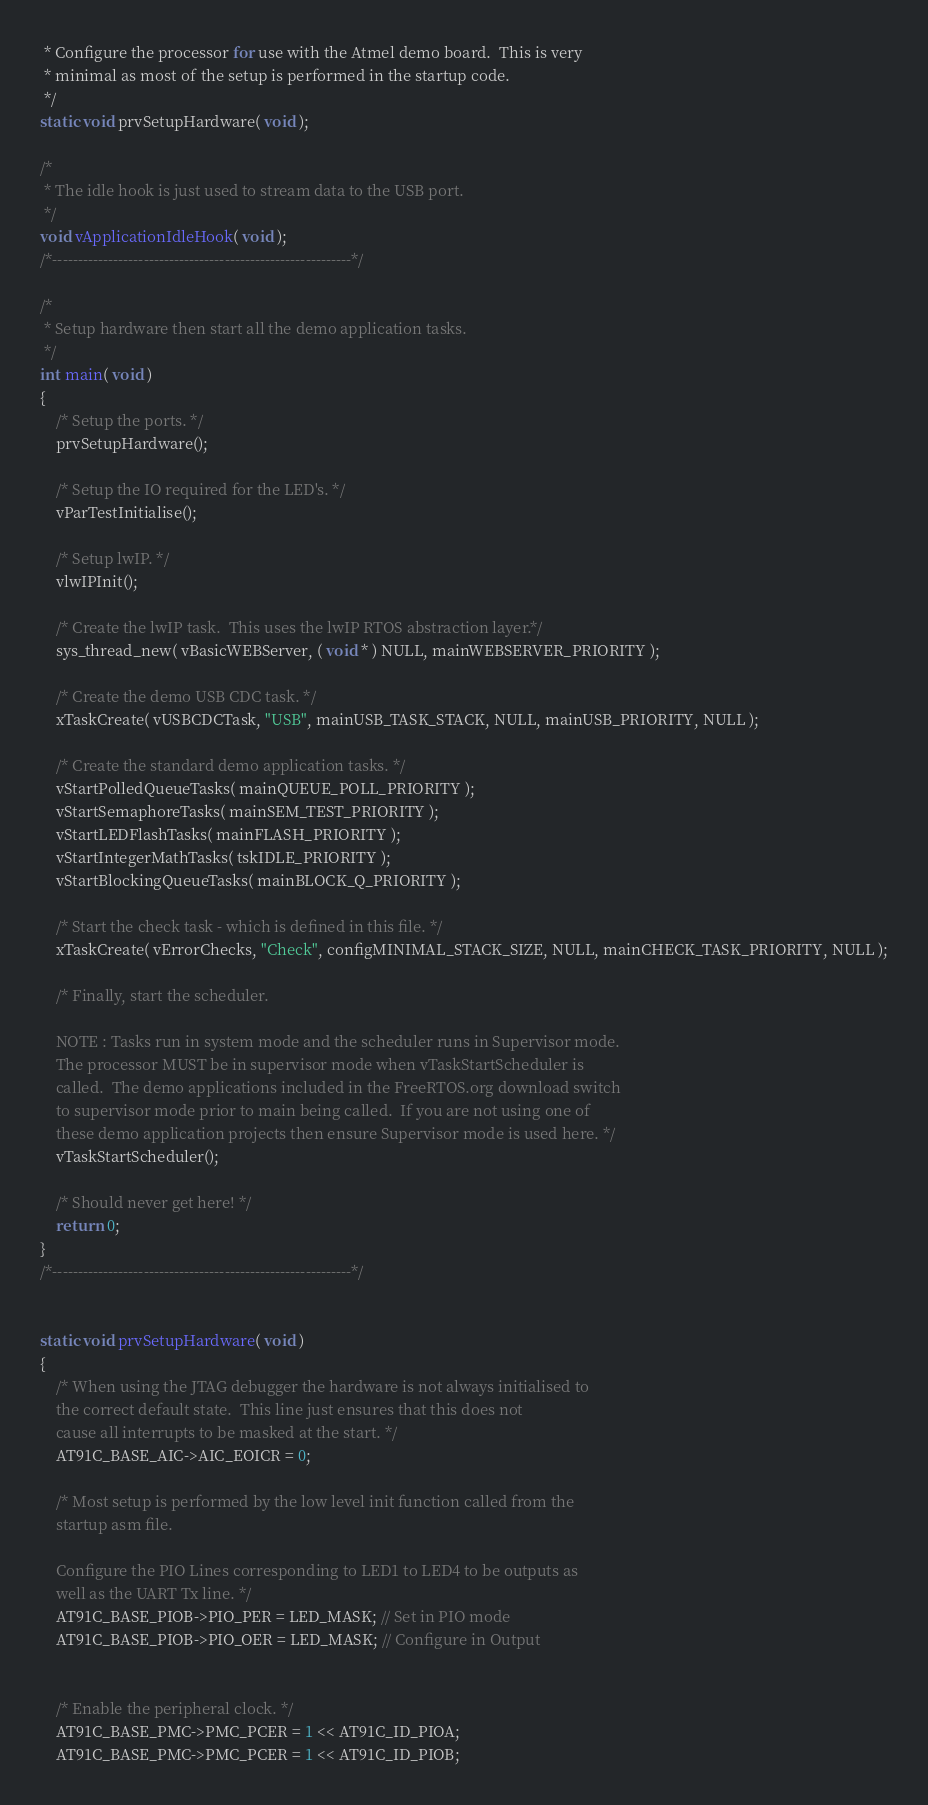Convert code to text. <code><loc_0><loc_0><loc_500><loc_500><_C_> * Configure the processor for use with the Atmel demo board.  This is very
 * minimal as most of the setup is performed in the startup code.
 */
static void prvSetupHardware( void );

/*
 * The idle hook is just used to stream data to the USB port.
 */
void vApplicationIdleHook( void );
/*-----------------------------------------------------------*/

/*
 * Setup hardware then start all the demo application tasks.
 */
int main( void )
{
	/* Setup the ports. */
	prvSetupHardware();

	/* Setup the IO required for the LED's. */
	vParTestInitialise();

	/* Setup lwIP. */
    vlwIPInit();

	/* Create the lwIP task.  This uses the lwIP RTOS abstraction layer.*/
    sys_thread_new( vBasicWEBServer, ( void * ) NULL, mainWEBSERVER_PRIORITY );

	/* Create the demo USB CDC task. */
	xTaskCreate( vUSBCDCTask, "USB", mainUSB_TASK_STACK, NULL, mainUSB_PRIORITY, NULL );

	/* Create the standard demo application tasks. */
	vStartPolledQueueTasks( mainQUEUE_POLL_PRIORITY );
	vStartSemaphoreTasks( mainSEM_TEST_PRIORITY );
	vStartLEDFlashTasks( mainFLASH_PRIORITY );
	vStartIntegerMathTasks( tskIDLE_PRIORITY );
	vStartBlockingQueueTasks( mainBLOCK_Q_PRIORITY );

	/* Start the check task - which is defined in this file. */
    xTaskCreate( vErrorChecks, "Check", configMINIMAL_STACK_SIZE, NULL, mainCHECK_TASK_PRIORITY, NULL );

	/* Finally, start the scheduler.

	NOTE : Tasks run in system mode and the scheduler runs in Supervisor mode.
	The processor MUST be in supervisor mode when vTaskStartScheduler is
	called.  The demo applications included in the FreeRTOS.org download switch
	to supervisor mode prior to main being called.  If you are not using one of
	these demo application projects then ensure Supervisor mode is used here. */
	vTaskStartScheduler();

	/* Should never get here! */
	return 0;
}
/*-----------------------------------------------------------*/


static void prvSetupHardware( void )
{
	/* When using the JTAG debugger the hardware is not always initialised to
	the correct default state.  This line just ensures that this does not
	cause all interrupts to be masked at the start. */
	AT91C_BASE_AIC->AIC_EOICR = 0;

	/* Most setup is performed by the low level init function called from the
	startup asm file.

	Configure the PIO Lines corresponding to LED1 to LED4 to be outputs as
	well as the UART Tx line. */
	AT91C_BASE_PIOB->PIO_PER = LED_MASK; // Set in PIO mode
	AT91C_BASE_PIOB->PIO_OER = LED_MASK; // Configure in Output


	/* Enable the peripheral clock. */
    AT91C_BASE_PMC->PMC_PCER = 1 << AT91C_ID_PIOA;
    AT91C_BASE_PMC->PMC_PCER = 1 << AT91C_ID_PIOB;</code> 